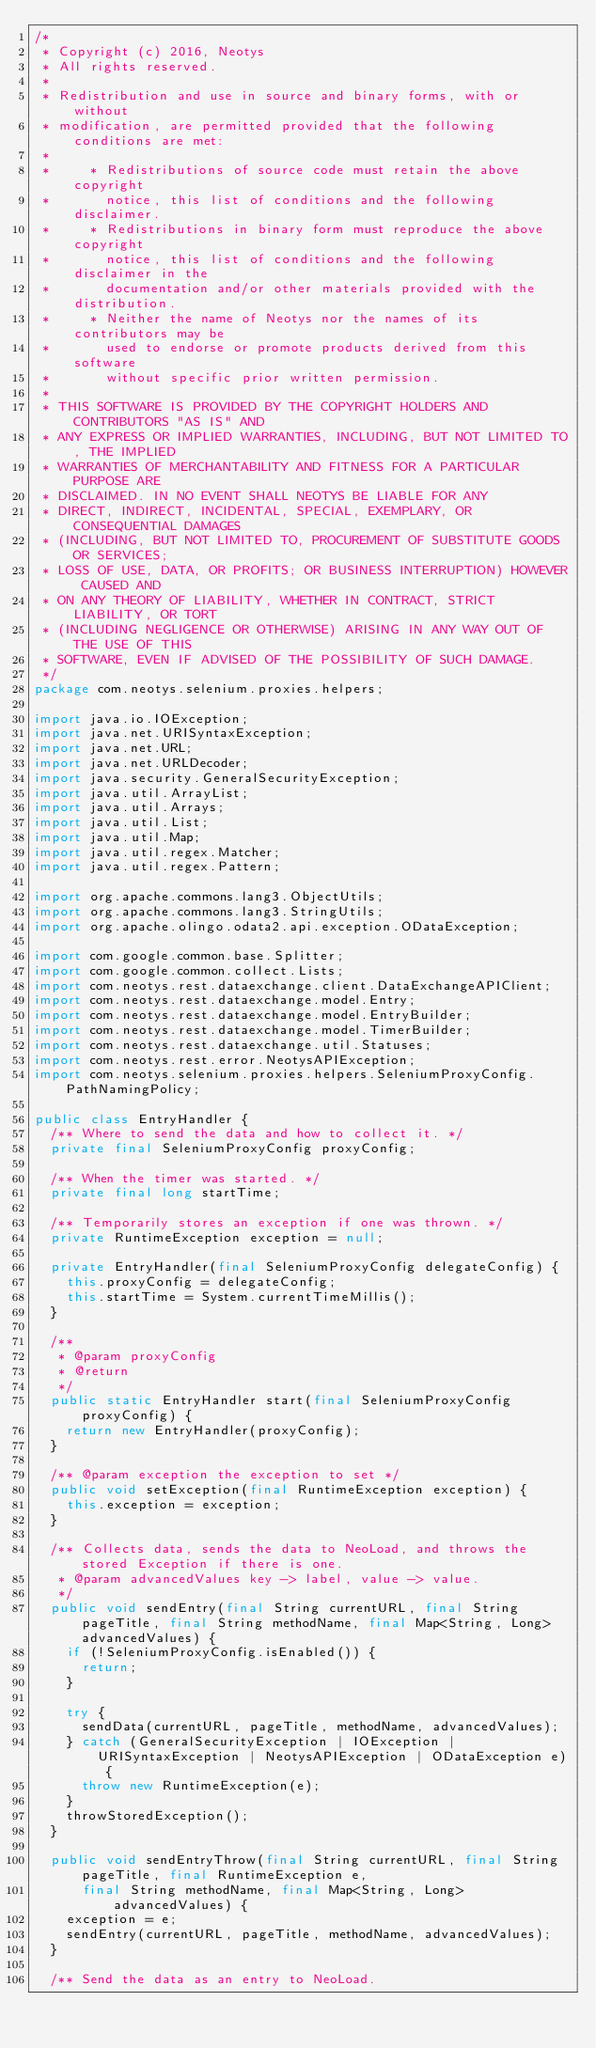<code> <loc_0><loc_0><loc_500><loc_500><_Java_>/*
 * Copyright (c) 2016, Neotys
 * All rights reserved.
 *
 * Redistribution and use in source and binary forms, with or without
 * modification, are permitted provided that the following conditions are met:
 *
 *     * Redistributions of source code must retain the above copyright
 *       notice, this list of conditions and the following disclaimer.
 *     * Redistributions in binary form must reproduce the above copyright
 *       notice, this list of conditions and the following disclaimer in the
 *       documentation and/or other materials provided with the distribution.
 *     * Neither the name of Neotys nor the names of its contributors may be
 *       used to endorse or promote products derived from this software
 *       without specific prior written permission.
 *
 * THIS SOFTWARE IS PROVIDED BY THE COPYRIGHT HOLDERS AND CONTRIBUTORS "AS IS" AND
 * ANY EXPRESS OR IMPLIED WARRANTIES, INCLUDING, BUT NOT LIMITED TO, THE IMPLIED
 * WARRANTIES OF MERCHANTABILITY AND FITNESS FOR A PARTICULAR PURPOSE ARE
 * DISCLAIMED. IN NO EVENT SHALL NEOTYS BE LIABLE FOR ANY
 * DIRECT, INDIRECT, INCIDENTAL, SPECIAL, EXEMPLARY, OR CONSEQUENTIAL DAMAGES
 * (INCLUDING, BUT NOT LIMITED TO, PROCUREMENT OF SUBSTITUTE GOODS OR SERVICES;
 * LOSS OF USE, DATA, OR PROFITS; OR BUSINESS INTERRUPTION) HOWEVER CAUSED AND
 * ON ANY THEORY OF LIABILITY, WHETHER IN CONTRACT, STRICT LIABILITY, OR TORT
 * (INCLUDING NEGLIGENCE OR OTHERWISE) ARISING IN ANY WAY OUT OF THE USE OF THIS
 * SOFTWARE, EVEN IF ADVISED OF THE POSSIBILITY OF SUCH DAMAGE.
 */
package com.neotys.selenium.proxies.helpers;

import java.io.IOException;
import java.net.URISyntaxException;
import java.net.URL;
import java.net.URLDecoder;
import java.security.GeneralSecurityException;
import java.util.ArrayList;
import java.util.Arrays;
import java.util.List;
import java.util.Map;
import java.util.regex.Matcher;
import java.util.regex.Pattern;

import org.apache.commons.lang3.ObjectUtils;
import org.apache.commons.lang3.StringUtils;
import org.apache.olingo.odata2.api.exception.ODataException;

import com.google.common.base.Splitter;
import com.google.common.collect.Lists;
import com.neotys.rest.dataexchange.client.DataExchangeAPIClient;
import com.neotys.rest.dataexchange.model.Entry;
import com.neotys.rest.dataexchange.model.EntryBuilder;
import com.neotys.rest.dataexchange.model.TimerBuilder;
import com.neotys.rest.dataexchange.util.Statuses;
import com.neotys.rest.error.NeotysAPIException;
import com.neotys.selenium.proxies.helpers.SeleniumProxyConfig.PathNamingPolicy;

public class EntryHandler {
	/** Where to send the data and how to collect it. */
	private final SeleniumProxyConfig proxyConfig;

	/** When the timer was started. */
	private final long startTime;

	/** Temporarily stores an exception if one was thrown. */
	private RuntimeException exception = null;

	private EntryHandler(final SeleniumProxyConfig delegateConfig) {
		this.proxyConfig = delegateConfig;
		this.startTime = System.currentTimeMillis();
	}

	/**
	 * @param proxyConfig
	 * @return
	 */
	public static EntryHandler start(final SeleniumProxyConfig proxyConfig) {
		return new EntryHandler(proxyConfig);
	}

	/** @param exception the exception to set */
	public void setException(final RuntimeException exception) {
		this.exception = exception;
	}

	/** Collects data, sends the data to NeoLoad, and throws the stored Exception if there is one.
	 * @param advancedValues key -> label, value -> value.
	 */
	public void sendEntry(final String currentURL, final String pageTitle, final String methodName, final Map<String, Long> advancedValues) {
		if (!SeleniumProxyConfig.isEnabled()) {
			return;
		}

		try {
			sendData(currentURL, pageTitle, methodName, advancedValues);
		} catch (GeneralSecurityException | IOException | URISyntaxException | NeotysAPIException | ODataException e) {
			throw new RuntimeException(e);
		}
		throwStoredException();
	}

	public void sendEntryThrow(final String currentURL, final String pageTitle, final RuntimeException e,
			final String methodName, final Map<String, Long> advancedValues) {
		exception = e;
		sendEntry(currentURL, pageTitle, methodName, advancedValues);
	}

	/** Send the data as an entry to NeoLoad.</code> 